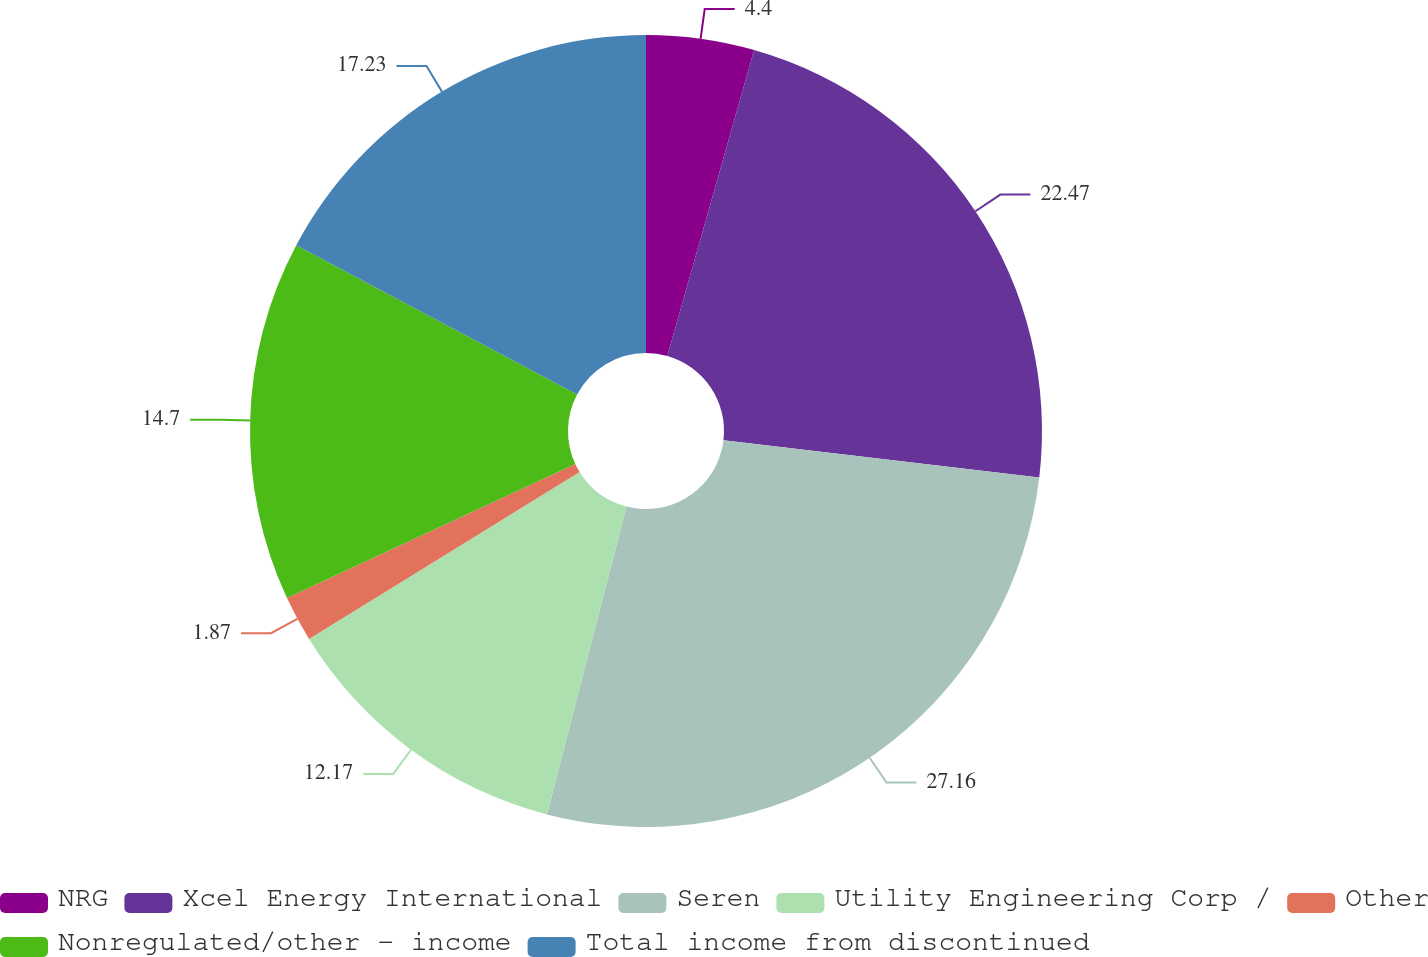<chart> <loc_0><loc_0><loc_500><loc_500><pie_chart><fcel>NRG<fcel>Xcel Energy International<fcel>Seren<fcel>Utility Engineering Corp /<fcel>Other<fcel>Nonregulated/other - income<fcel>Total income from discontinued<nl><fcel>4.4%<fcel>22.47%<fcel>27.15%<fcel>12.17%<fcel>1.87%<fcel>14.7%<fcel>17.23%<nl></chart> 